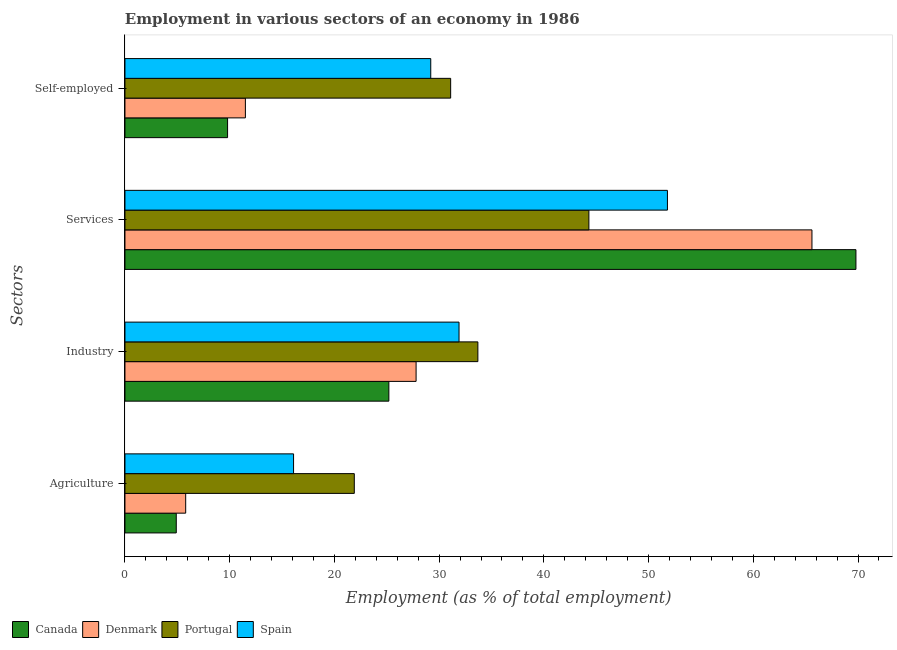How many groups of bars are there?
Ensure brevity in your answer.  4. Are the number of bars per tick equal to the number of legend labels?
Your response must be concise. Yes. How many bars are there on the 1st tick from the bottom?
Your answer should be very brief. 4. What is the label of the 4th group of bars from the top?
Offer a very short reply. Agriculture. What is the percentage of workers in industry in Denmark?
Your answer should be compact. 27.8. Across all countries, what is the maximum percentage of workers in industry?
Keep it short and to the point. 33.7. Across all countries, what is the minimum percentage of self employed workers?
Provide a short and direct response. 9.8. In which country was the percentage of workers in industry maximum?
Keep it short and to the point. Portugal. What is the total percentage of workers in services in the graph?
Offer a terse response. 231.5. What is the difference between the percentage of workers in agriculture in Canada and that in Portugal?
Provide a succinct answer. -17. What is the difference between the percentage of workers in services in Canada and the percentage of workers in agriculture in Portugal?
Make the answer very short. 47.9. What is the average percentage of workers in industry per country?
Provide a short and direct response. 29.65. What is the difference between the percentage of workers in services and percentage of workers in agriculture in Portugal?
Offer a terse response. 22.4. What is the ratio of the percentage of workers in services in Denmark to that in Portugal?
Keep it short and to the point. 1.48. Is the percentage of self employed workers in Spain less than that in Portugal?
Your response must be concise. Yes. What is the difference between the highest and the second highest percentage of workers in services?
Your answer should be very brief. 4.2. What is the difference between the highest and the lowest percentage of workers in agriculture?
Keep it short and to the point. 17. In how many countries, is the percentage of self employed workers greater than the average percentage of self employed workers taken over all countries?
Provide a succinct answer. 2. Is the sum of the percentage of workers in services in Canada and Denmark greater than the maximum percentage of workers in industry across all countries?
Make the answer very short. Yes. Is it the case that in every country, the sum of the percentage of workers in agriculture and percentage of workers in services is greater than the sum of percentage of self employed workers and percentage of workers in industry?
Give a very brief answer. No. What does the 4th bar from the bottom in Agriculture represents?
Offer a terse response. Spain. Is it the case that in every country, the sum of the percentage of workers in agriculture and percentage of workers in industry is greater than the percentage of workers in services?
Make the answer very short. No. How many bars are there?
Offer a terse response. 16. How many countries are there in the graph?
Provide a succinct answer. 4. What is the difference between two consecutive major ticks on the X-axis?
Keep it short and to the point. 10. Does the graph contain any zero values?
Make the answer very short. No. How many legend labels are there?
Offer a very short reply. 4. How are the legend labels stacked?
Your answer should be very brief. Horizontal. What is the title of the graph?
Offer a very short reply. Employment in various sectors of an economy in 1986. Does "Low income" appear as one of the legend labels in the graph?
Your answer should be compact. No. What is the label or title of the X-axis?
Give a very brief answer. Employment (as % of total employment). What is the label or title of the Y-axis?
Your answer should be very brief. Sectors. What is the Employment (as % of total employment) of Canada in Agriculture?
Offer a terse response. 4.9. What is the Employment (as % of total employment) in Denmark in Agriculture?
Your answer should be very brief. 5.8. What is the Employment (as % of total employment) in Portugal in Agriculture?
Offer a very short reply. 21.9. What is the Employment (as % of total employment) in Spain in Agriculture?
Your answer should be very brief. 16.1. What is the Employment (as % of total employment) in Canada in Industry?
Ensure brevity in your answer.  25.2. What is the Employment (as % of total employment) of Denmark in Industry?
Provide a succinct answer. 27.8. What is the Employment (as % of total employment) of Portugal in Industry?
Ensure brevity in your answer.  33.7. What is the Employment (as % of total employment) in Spain in Industry?
Offer a terse response. 31.9. What is the Employment (as % of total employment) in Canada in Services?
Provide a succinct answer. 69.8. What is the Employment (as % of total employment) in Denmark in Services?
Give a very brief answer. 65.6. What is the Employment (as % of total employment) in Portugal in Services?
Give a very brief answer. 44.3. What is the Employment (as % of total employment) in Spain in Services?
Your answer should be very brief. 51.8. What is the Employment (as % of total employment) in Canada in Self-employed?
Provide a short and direct response. 9.8. What is the Employment (as % of total employment) of Portugal in Self-employed?
Offer a terse response. 31.1. What is the Employment (as % of total employment) in Spain in Self-employed?
Give a very brief answer. 29.2. Across all Sectors, what is the maximum Employment (as % of total employment) in Canada?
Offer a terse response. 69.8. Across all Sectors, what is the maximum Employment (as % of total employment) in Denmark?
Make the answer very short. 65.6. Across all Sectors, what is the maximum Employment (as % of total employment) in Portugal?
Offer a very short reply. 44.3. Across all Sectors, what is the maximum Employment (as % of total employment) of Spain?
Your answer should be compact. 51.8. Across all Sectors, what is the minimum Employment (as % of total employment) of Canada?
Offer a very short reply. 4.9. Across all Sectors, what is the minimum Employment (as % of total employment) in Denmark?
Ensure brevity in your answer.  5.8. Across all Sectors, what is the minimum Employment (as % of total employment) in Portugal?
Provide a short and direct response. 21.9. Across all Sectors, what is the minimum Employment (as % of total employment) of Spain?
Provide a short and direct response. 16.1. What is the total Employment (as % of total employment) in Canada in the graph?
Your answer should be very brief. 109.7. What is the total Employment (as % of total employment) in Denmark in the graph?
Offer a very short reply. 110.7. What is the total Employment (as % of total employment) in Portugal in the graph?
Give a very brief answer. 131. What is the total Employment (as % of total employment) of Spain in the graph?
Provide a short and direct response. 129. What is the difference between the Employment (as % of total employment) in Canada in Agriculture and that in Industry?
Your response must be concise. -20.3. What is the difference between the Employment (as % of total employment) in Denmark in Agriculture and that in Industry?
Make the answer very short. -22. What is the difference between the Employment (as % of total employment) of Spain in Agriculture and that in Industry?
Ensure brevity in your answer.  -15.8. What is the difference between the Employment (as % of total employment) of Canada in Agriculture and that in Services?
Keep it short and to the point. -64.9. What is the difference between the Employment (as % of total employment) in Denmark in Agriculture and that in Services?
Give a very brief answer. -59.8. What is the difference between the Employment (as % of total employment) in Portugal in Agriculture and that in Services?
Make the answer very short. -22.4. What is the difference between the Employment (as % of total employment) of Spain in Agriculture and that in Services?
Keep it short and to the point. -35.7. What is the difference between the Employment (as % of total employment) of Canada in Agriculture and that in Self-employed?
Offer a terse response. -4.9. What is the difference between the Employment (as % of total employment) of Denmark in Agriculture and that in Self-employed?
Offer a very short reply. -5.7. What is the difference between the Employment (as % of total employment) of Portugal in Agriculture and that in Self-employed?
Your answer should be very brief. -9.2. What is the difference between the Employment (as % of total employment) of Canada in Industry and that in Services?
Make the answer very short. -44.6. What is the difference between the Employment (as % of total employment) of Denmark in Industry and that in Services?
Give a very brief answer. -37.8. What is the difference between the Employment (as % of total employment) in Portugal in Industry and that in Services?
Your response must be concise. -10.6. What is the difference between the Employment (as % of total employment) in Spain in Industry and that in Services?
Provide a short and direct response. -19.9. What is the difference between the Employment (as % of total employment) of Canada in Industry and that in Self-employed?
Provide a succinct answer. 15.4. What is the difference between the Employment (as % of total employment) of Denmark in Industry and that in Self-employed?
Ensure brevity in your answer.  16.3. What is the difference between the Employment (as % of total employment) in Spain in Industry and that in Self-employed?
Keep it short and to the point. 2.7. What is the difference between the Employment (as % of total employment) in Canada in Services and that in Self-employed?
Offer a terse response. 60. What is the difference between the Employment (as % of total employment) in Denmark in Services and that in Self-employed?
Offer a very short reply. 54.1. What is the difference between the Employment (as % of total employment) in Portugal in Services and that in Self-employed?
Your response must be concise. 13.2. What is the difference between the Employment (as % of total employment) in Spain in Services and that in Self-employed?
Offer a terse response. 22.6. What is the difference between the Employment (as % of total employment) of Canada in Agriculture and the Employment (as % of total employment) of Denmark in Industry?
Provide a short and direct response. -22.9. What is the difference between the Employment (as % of total employment) of Canada in Agriculture and the Employment (as % of total employment) of Portugal in Industry?
Keep it short and to the point. -28.8. What is the difference between the Employment (as % of total employment) in Canada in Agriculture and the Employment (as % of total employment) in Spain in Industry?
Your answer should be compact. -27. What is the difference between the Employment (as % of total employment) in Denmark in Agriculture and the Employment (as % of total employment) in Portugal in Industry?
Your answer should be very brief. -27.9. What is the difference between the Employment (as % of total employment) of Denmark in Agriculture and the Employment (as % of total employment) of Spain in Industry?
Ensure brevity in your answer.  -26.1. What is the difference between the Employment (as % of total employment) in Canada in Agriculture and the Employment (as % of total employment) in Denmark in Services?
Your response must be concise. -60.7. What is the difference between the Employment (as % of total employment) of Canada in Agriculture and the Employment (as % of total employment) of Portugal in Services?
Keep it short and to the point. -39.4. What is the difference between the Employment (as % of total employment) in Canada in Agriculture and the Employment (as % of total employment) in Spain in Services?
Your response must be concise. -46.9. What is the difference between the Employment (as % of total employment) in Denmark in Agriculture and the Employment (as % of total employment) in Portugal in Services?
Provide a short and direct response. -38.5. What is the difference between the Employment (as % of total employment) in Denmark in Agriculture and the Employment (as % of total employment) in Spain in Services?
Provide a succinct answer. -46. What is the difference between the Employment (as % of total employment) in Portugal in Agriculture and the Employment (as % of total employment) in Spain in Services?
Offer a very short reply. -29.9. What is the difference between the Employment (as % of total employment) in Canada in Agriculture and the Employment (as % of total employment) in Portugal in Self-employed?
Offer a very short reply. -26.2. What is the difference between the Employment (as % of total employment) in Canada in Agriculture and the Employment (as % of total employment) in Spain in Self-employed?
Your response must be concise. -24.3. What is the difference between the Employment (as % of total employment) of Denmark in Agriculture and the Employment (as % of total employment) of Portugal in Self-employed?
Provide a succinct answer. -25.3. What is the difference between the Employment (as % of total employment) of Denmark in Agriculture and the Employment (as % of total employment) of Spain in Self-employed?
Make the answer very short. -23.4. What is the difference between the Employment (as % of total employment) of Portugal in Agriculture and the Employment (as % of total employment) of Spain in Self-employed?
Give a very brief answer. -7.3. What is the difference between the Employment (as % of total employment) in Canada in Industry and the Employment (as % of total employment) in Denmark in Services?
Ensure brevity in your answer.  -40.4. What is the difference between the Employment (as % of total employment) in Canada in Industry and the Employment (as % of total employment) in Portugal in Services?
Your answer should be very brief. -19.1. What is the difference between the Employment (as % of total employment) of Canada in Industry and the Employment (as % of total employment) of Spain in Services?
Provide a short and direct response. -26.6. What is the difference between the Employment (as % of total employment) of Denmark in Industry and the Employment (as % of total employment) of Portugal in Services?
Provide a succinct answer. -16.5. What is the difference between the Employment (as % of total employment) in Portugal in Industry and the Employment (as % of total employment) in Spain in Services?
Keep it short and to the point. -18.1. What is the difference between the Employment (as % of total employment) of Canada in Industry and the Employment (as % of total employment) of Denmark in Self-employed?
Ensure brevity in your answer.  13.7. What is the difference between the Employment (as % of total employment) in Canada in Industry and the Employment (as % of total employment) in Portugal in Self-employed?
Offer a very short reply. -5.9. What is the difference between the Employment (as % of total employment) of Denmark in Industry and the Employment (as % of total employment) of Portugal in Self-employed?
Provide a succinct answer. -3.3. What is the difference between the Employment (as % of total employment) of Denmark in Industry and the Employment (as % of total employment) of Spain in Self-employed?
Offer a terse response. -1.4. What is the difference between the Employment (as % of total employment) in Portugal in Industry and the Employment (as % of total employment) in Spain in Self-employed?
Ensure brevity in your answer.  4.5. What is the difference between the Employment (as % of total employment) of Canada in Services and the Employment (as % of total employment) of Denmark in Self-employed?
Ensure brevity in your answer.  58.3. What is the difference between the Employment (as % of total employment) of Canada in Services and the Employment (as % of total employment) of Portugal in Self-employed?
Offer a terse response. 38.7. What is the difference between the Employment (as % of total employment) in Canada in Services and the Employment (as % of total employment) in Spain in Self-employed?
Ensure brevity in your answer.  40.6. What is the difference between the Employment (as % of total employment) in Denmark in Services and the Employment (as % of total employment) in Portugal in Self-employed?
Ensure brevity in your answer.  34.5. What is the difference between the Employment (as % of total employment) of Denmark in Services and the Employment (as % of total employment) of Spain in Self-employed?
Your response must be concise. 36.4. What is the average Employment (as % of total employment) in Canada per Sectors?
Keep it short and to the point. 27.43. What is the average Employment (as % of total employment) of Denmark per Sectors?
Your response must be concise. 27.68. What is the average Employment (as % of total employment) in Portugal per Sectors?
Your response must be concise. 32.75. What is the average Employment (as % of total employment) in Spain per Sectors?
Your answer should be compact. 32.25. What is the difference between the Employment (as % of total employment) in Canada and Employment (as % of total employment) in Portugal in Agriculture?
Your answer should be very brief. -17. What is the difference between the Employment (as % of total employment) of Canada and Employment (as % of total employment) of Spain in Agriculture?
Keep it short and to the point. -11.2. What is the difference between the Employment (as % of total employment) in Denmark and Employment (as % of total employment) in Portugal in Agriculture?
Ensure brevity in your answer.  -16.1. What is the difference between the Employment (as % of total employment) of Canada and Employment (as % of total employment) of Denmark in Industry?
Give a very brief answer. -2.6. What is the difference between the Employment (as % of total employment) in Canada and Employment (as % of total employment) in Portugal in Services?
Make the answer very short. 25.5. What is the difference between the Employment (as % of total employment) of Denmark and Employment (as % of total employment) of Portugal in Services?
Provide a succinct answer. 21.3. What is the difference between the Employment (as % of total employment) in Portugal and Employment (as % of total employment) in Spain in Services?
Provide a short and direct response. -7.5. What is the difference between the Employment (as % of total employment) in Canada and Employment (as % of total employment) in Denmark in Self-employed?
Your answer should be compact. -1.7. What is the difference between the Employment (as % of total employment) of Canada and Employment (as % of total employment) of Portugal in Self-employed?
Keep it short and to the point. -21.3. What is the difference between the Employment (as % of total employment) in Canada and Employment (as % of total employment) in Spain in Self-employed?
Your response must be concise. -19.4. What is the difference between the Employment (as % of total employment) in Denmark and Employment (as % of total employment) in Portugal in Self-employed?
Keep it short and to the point. -19.6. What is the difference between the Employment (as % of total employment) in Denmark and Employment (as % of total employment) in Spain in Self-employed?
Make the answer very short. -17.7. What is the ratio of the Employment (as % of total employment) of Canada in Agriculture to that in Industry?
Give a very brief answer. 0.19. What is the ratio of the Employment (as % of total employment) of Denmark in Agriculture to that in Industry?
Keep it short and to the point. 0.21. What is the ratio of the Employment (as % of total employment) of Portugal in Agriculture to that in Industry?
Ensure brevity in your answer.  0.65. What is the ratio of the Employment (as % of total employment) of Spain in Agriculture to that in Industry?
Ensure brevity in your answer.  0.5. What is the ratio of the Employment (as % of total employment) of Canada in Agriculture to that in Services?
Ensure brevity in your answer.  0.07. What is the ratio of the Employment (as % of total employment) of Denmark in Agriculture to that in Services?
Give a very brief answer. 0.09. What is the ratio of the Employment (as % of total employment) of Portugal in Agriculture to that in Services?
Provide a short and direct response. 0.49. What is the ratio of the Employment (as % of total employment) in Spain in Agriculture to that in Services?
Give a very brief answer. 0.31. What is the ratio of the Employment (as % of total employment) of Canada in Agriculture to that in Self-employed?
Ensure brevity in your answer.  0.5. What is the ratio of the Employment (as % of total employment) of Denmark in Agriculture to that in Self-employed?
Your response must be concise. 0.5. What is the ratio of the Employment (as % of total employment) of Portugal in Agriculture to that in Self-employed?
Provide a short and direct response. 0.7. What is the ratio of the Employment (as % of total employment) of Spain in Agriculture to that in Self-employed?
Your answer should be compact. 0.55. What is the ratio of the Employment (as % of total employment) of Canada in Industry to that in Services?
Keep it short and to the point. 0.36. What is the ratio of the Employment (as % of total employment) of Denmark in Industry to that in Services?
Your answer should be very brief. 0.42. What is the ratio of the Employment (as % of total employment) in Portugal in Industry to that in Services?
Give a very brief answer. 0.76. What is the ratio of the Employment (as % of total employment) in Spain in Industry to that in Services?
Offer a terse response. 0.62. What is the ratio of the Employment (as % of total employment) of Canada in Industry to that in Self-employed?
Your response must be concise. 2.57. What is the ratio of the Employment (as % of total employment) in Denmark in Industry to that in Self-employed?
Keep it short and to the point. 2.42. What is the ratio of the Employment (as % of total employment) in Portugal in Industry to that in Self-employed?
Your answer should be compact. 1.08. What is the ratio of the Employment (as % of total employment) of Spain in Industry to that in Self-employed?
Make the answer very short. 1.09. What is the ratio of the Employment (as % of total employment) in Canada in Services to that in Self-employed?
Offer a very short reply. 7.12. What is the ratio of the Employment (as % of total employment) in Denmark in Services to that in Self-employed?
Make the answer very short. 5.7. What is the ratio of the Employment (as % of total employment) of Portugal in Services to that in Self-employed?
Your answer should be compact. 1.42. What is the ratio of the Employment (as % of total employment) in Spain in Services to that in Self-employed?
Your answer should be very brief. 1.77. What is the difference between the highest and the second highest Employment (as % of total employment) of Canada?
Keep it short and to the point. 44.6. What is the difference between the highest and the second highest Employment (as % of total employment) in Denmark?
Your response must be concise. 37.8. What is the difference between the highest and the second highest Employment (as % of total employment) in Portugal?
Your answer should be very brief. 10.6. What is the difference between the highest and the second highest Employment (as % of total employment) of Spain?
Provide a short and direct response. 19.9. What is the difference between the highest and the lowest Employment (as % of total employment) in Canada?
Your answer should be compact. 64.9. What is the difference between the highest and the lowest Employment (as % of total employment) in Denmark?
Give a very brief answer. 59.8. What is the difference between the highest and the lowest Employment (as % of total employment) of Portugal?
Your response must be concise. 22.4. What is the difference between the highest and the lowest Employment (as % of total employment) of Spain?
Offer a terse response. 35.7. 